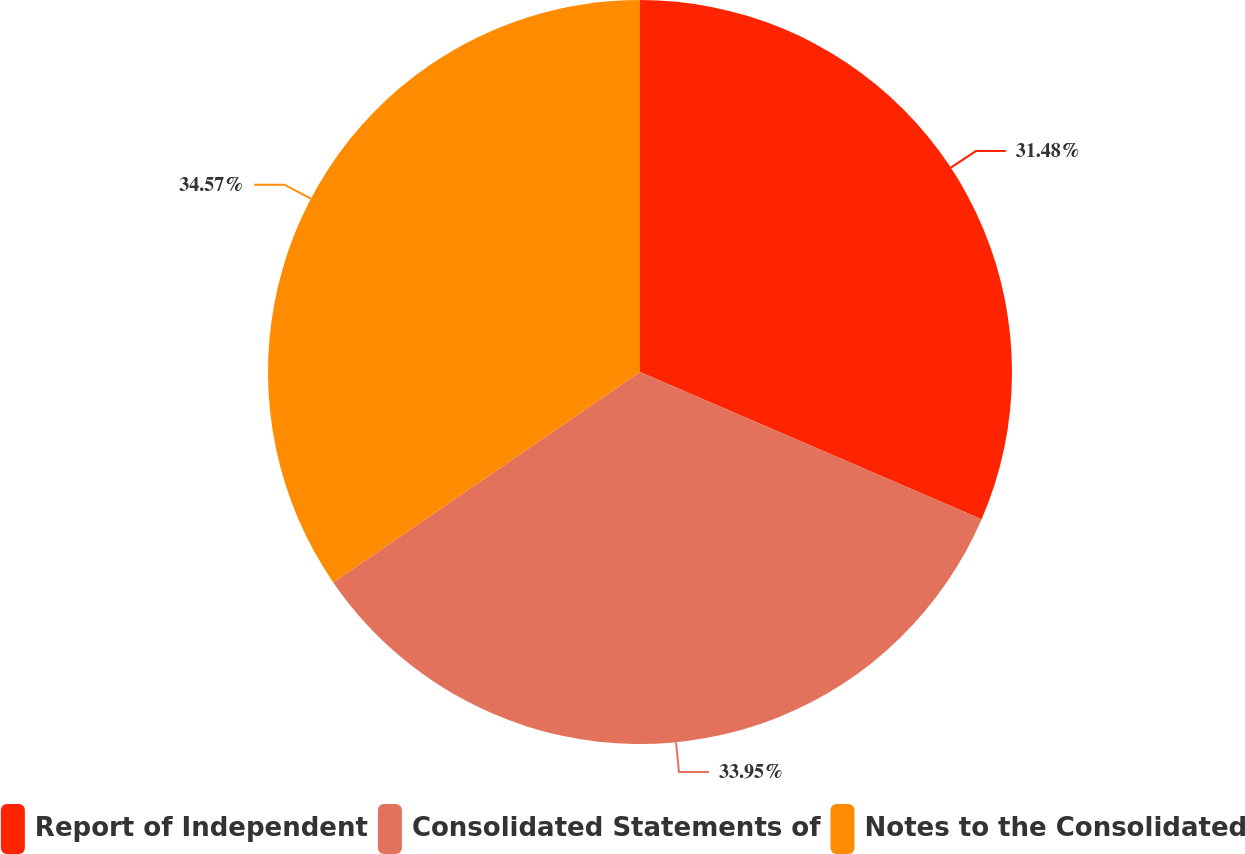<chart> <loc_0><loc_0><loc_500><loc_500><pie_chart><fcel>Report of Independent<fcel>Consolidated Statements of<fcel>Notes to the Consolidated<nl><fcel>31.48%<fcel>33.95%<fcel>34.57%<nl></chart> 